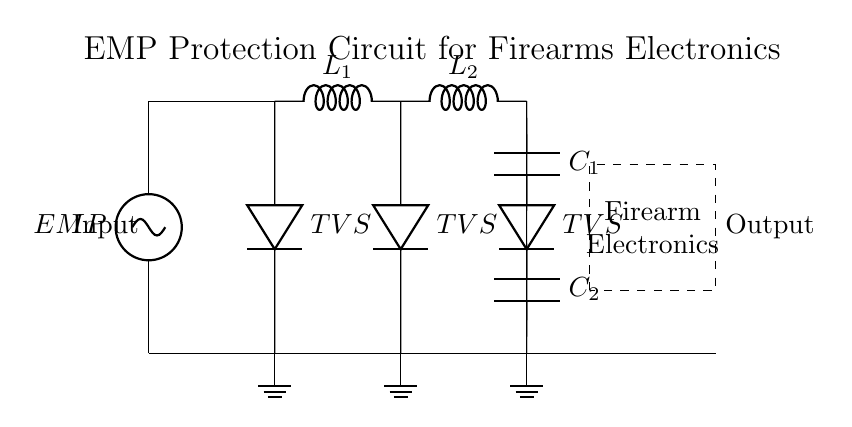What is the main function of the TVS components in this circuit? The Transient Voltage Suppressors (TVS) protect the sensitive electronics from voltage spikes caused by an EMP by clamping the voltage to a safe level.
Answer: Protection How many inductors are present in the circuit? There are two inductors labeled L1 and L2 in the circuit diagram, which contribute to filtering and transient response.
Answer: Two What type of components are used to store energy in this circuit? Capacitors C1 and C2 are used to store energy and provide additional filtering for the signal passing to the sensitive electronics.
Answer: Capacitors What does the dashed rectangle represent in the circuit? The dashed rectangle indicates the area containing the sensitive electronics of the firearm, which needs protection from the EMP.
Answer: Firearm Electronics What is the purpose of the ground connections in this circuit? The ground connections provide a common reference point for the circuit, which is essential for safety and proper functioning under EMP conditions.
Answer: Common reference How are the TVS devices connected in relation to the inductors? The TVS devices are connected in parallel to the inductors, which allows for effective suppression of voltage spikes while maintaining normal circuit operation.
Answer: Parallel 